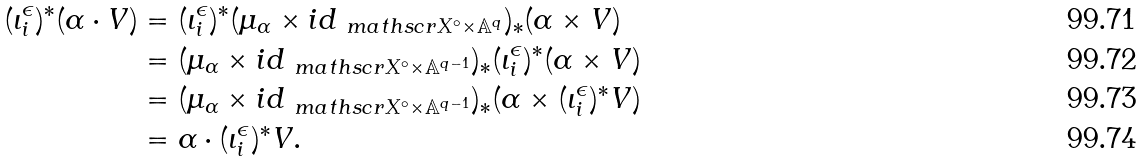<formula> <loc_0><loc_0><loc_500><loc_500>( \iota _ { i } ^ { \epsilon } ) ^ { \ast } ( \alpha \cdot V ) & = ( \iota _ { i } ^ { \epsilon } ) ^ { \ast } ( \mu _ { \alpha } \times i d _ { \ m a t h s c r { X } ^ { \circ } \times \mathbb { A } ^ { q } } ) _ { \ast } ( \alpha \times V ) \\ & = ( \mu _ { \alpha } \times i d _ { \ m a t h s c r { X } ^ { \circ } \times \mathbb { A } ^ { q - 1 } } ) _ { \ast } ( \iota _ { i } ^ { \epsilon } ) ^ { \ast } ( \alpha \times V ) \\ & = ( \mu _ { \alpha } \times i d _ { \ m a t h s c r { X } ^ { \circ } \times \mathbb { A } ^ { q - 1 } } ) _ { \ast } ( \alpha \times ( \iota _ { i } ^ { \epsilon } ) ^ { \ast } V ) \\ & = \alpha \cdot ( \iota _ { i } ^ { \epsilon } ) ^ { \ast } V .</formula> 